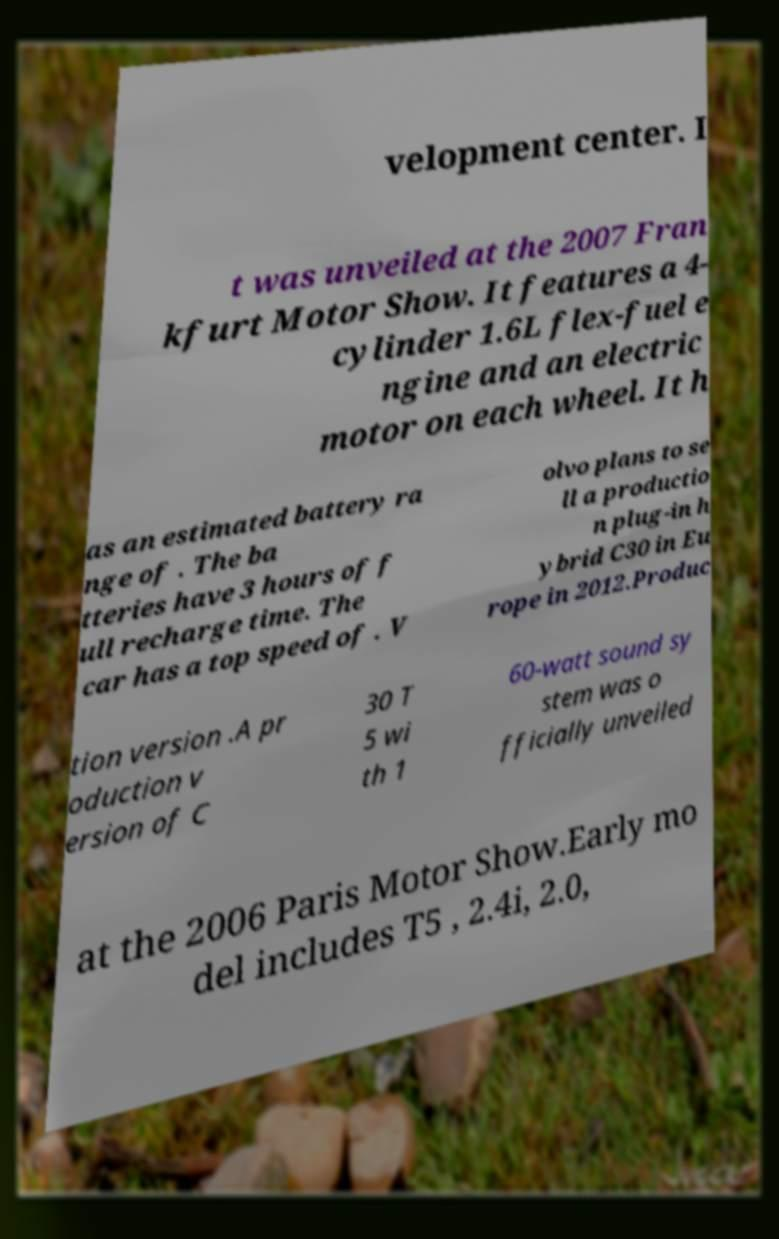Could you extract and type out the text from this image? velopment center. I t was unveiled at the 2007 Fran kfurt Motor Show. It features a 4- cylinder 1.6L flex-fuel e ngine and an electric motor on each wheel. It h as an estimated battery ra nge of . The ba tteries have 3 hours of f ull recharge time. The car has a top speed of . V olvo plans to se ll a productio n plug-in h ybrid C30 in Eu rope in 2012.Produc tion version .A pr oduction v ersion of C 30 T 5 wi th 1 60-watt sound sy stem was o fficially unveiled at the 2006 Paris Motor Show.Early mo del includes T5 , 2.4i, 2.0, 